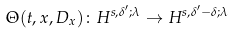<formula> <loc_0><loc_0><loc_500><loc_500>\Theta ( t , x , D _ { x } ) \colon H ^ { s , \delta ^ { \prime } ; \lambda } \to H ^ { s , \delta ^ { \prime } - \delta ; \lambda }</formula> 